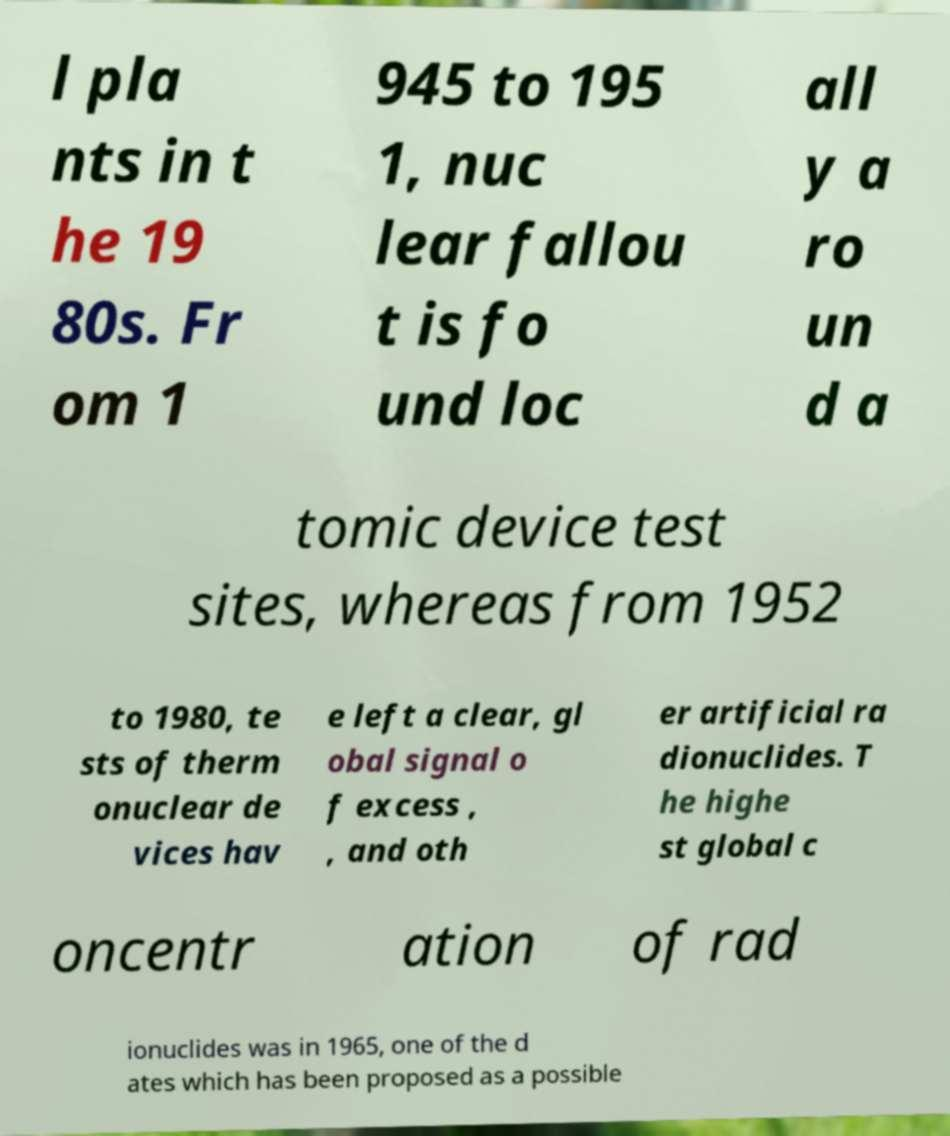For documentation purposes, I need the text within this image transcribed. Could you provide that? l pla nts in t he 19 80s. Fr om 1 945 to 195 1, nuc lear fallou t is fo und loc all y a ro un d a tomic device test sites, whereas from 1952 to 1980, te sts of therm onuclear de vices hav e left a clear, gl obal signal o f excess , , and oth er artificial ra dionuclides. T he highe st global c oncentr ation of rad ionuclides was in 1965, one of the d ates which has been proposed as a possible 